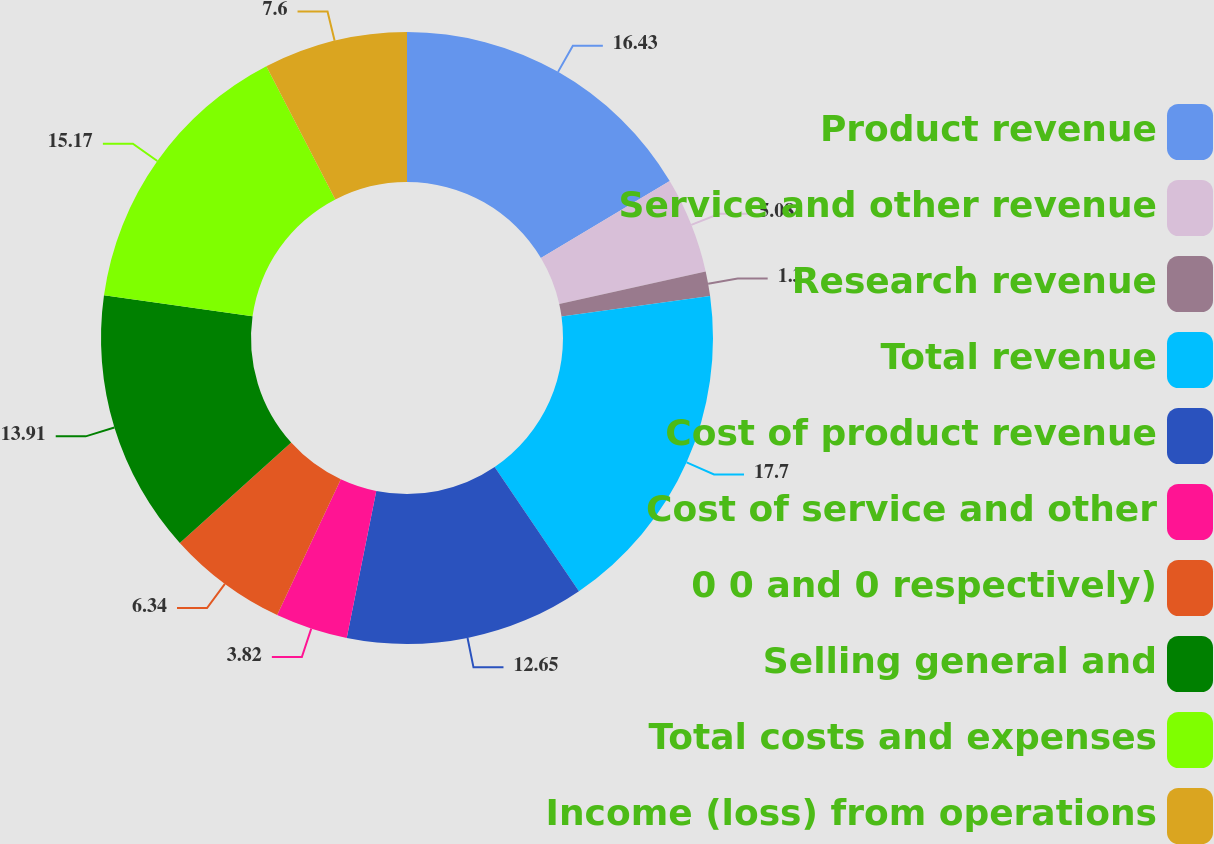Convert chart. <chart><loc_0><loc_0><loc_500><loc_500><pie_chart><fcel>Product revenue<fcel>Service and other revenue<fcel>Research revenue<fcel>Total revenue<fcel>Cost of product revenue<fcel>Cost of service and other<fcel>0 0 and 0 respectively)<fcel>Selling general and<fcel>Total costs and expenses<fcel>Income (loss) from operations<nl><fcel>16.43%<fcel>5.08%<fcel>1.3%<fcel>17.69%<fcel>12.65%<fcel>3.82%<fcel>6.34%<fcel>13.91%<fcel>15.17%<fcel>7.6%<nl></chart> 